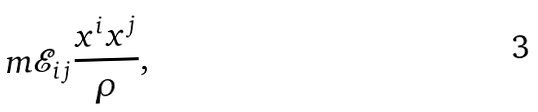Convert formula to latex. <formula><loc_0><loc_0><loc_500><loc_500>m \mathcal { E } _ { i j } \frac { x ^ { i } x ^ { j } } { \rho } ,</formula> 